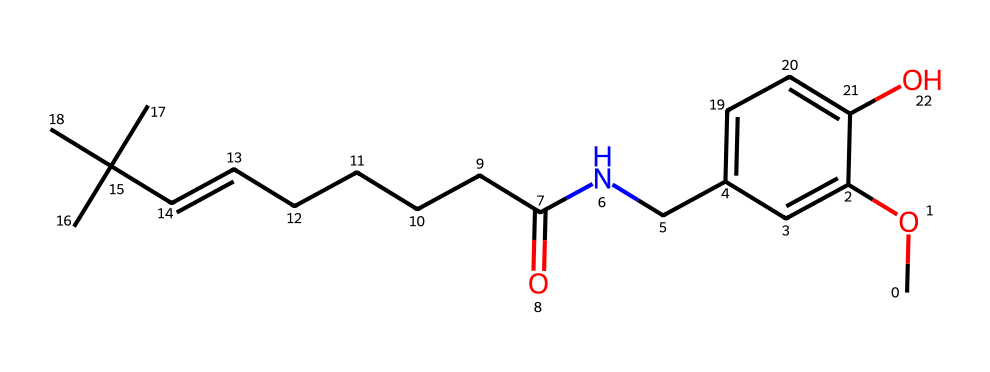What is the molecular formula of this compound? To determine the molecular formula, we need to count the number of each type of atom in the SMILES representation. In this case, we can identify carbon (C), hydrogen (H), nitrogen (N), and oxygen (O) in the structure. By counting, we find there are 22 carbon atoms, 35 hydrogen atoms, 1 nitrogen atom, and 3 oxygen atoms. Thus, the molecular formula is C22H35N1O3.
Answer: C22H35N1O3 How many rings are present in the structure? By examining the SMILES representation, we can look for any cyclic (ring) structures indicated by the lowercase letters followed by numbers. In this case, there is one ring indicated with 'c' (for aromatic carbons) where one part of the structure forms a complete loop. Thus, there is 1 ring in the structure.
Answer: 1 What functional groups are evident in the compound? The SMILES representation shows several functional groups: esters, amides, and alcohols, which can be deduced from the presence of -O- (ether/alcohol), -C(=O)- (carbonyl in amides), and -NH- (amine in the amide). Identifying these parts reveals these functional groups.
Answer: alcohol, amide What is the significance of the nitrogen atom in this compound? The presence of a nitrogen atom suggests the compound could have protein-like characteristics, often being involved in forming amides. In this case, it indicates a connection to protein structures and possibly enhancing flavor or bioactivity. This reasoning points to its role in the spiciness and overall character of the compound.
Answer: flavor enhancer What type of molecule is this most similar to? This compound is similar to capsaicin, which is known for its spiciness found in chili peppers. The structure shows a chain similar to that of capsaicin, indicating its similarity in chemical reactivity and function, particularly in food applications.
Answer: capsaicin What type of chemical bonds are primarily present in this structure? In this structure, the primary types of bonds are covalent bonds, which are formed between the atoms, especially seen in the carbon-hydrogen and carbon-oxygen linkages. The analysis confirms that covalent bonds dominate the molecular framework.
Answer: covalent bonds 